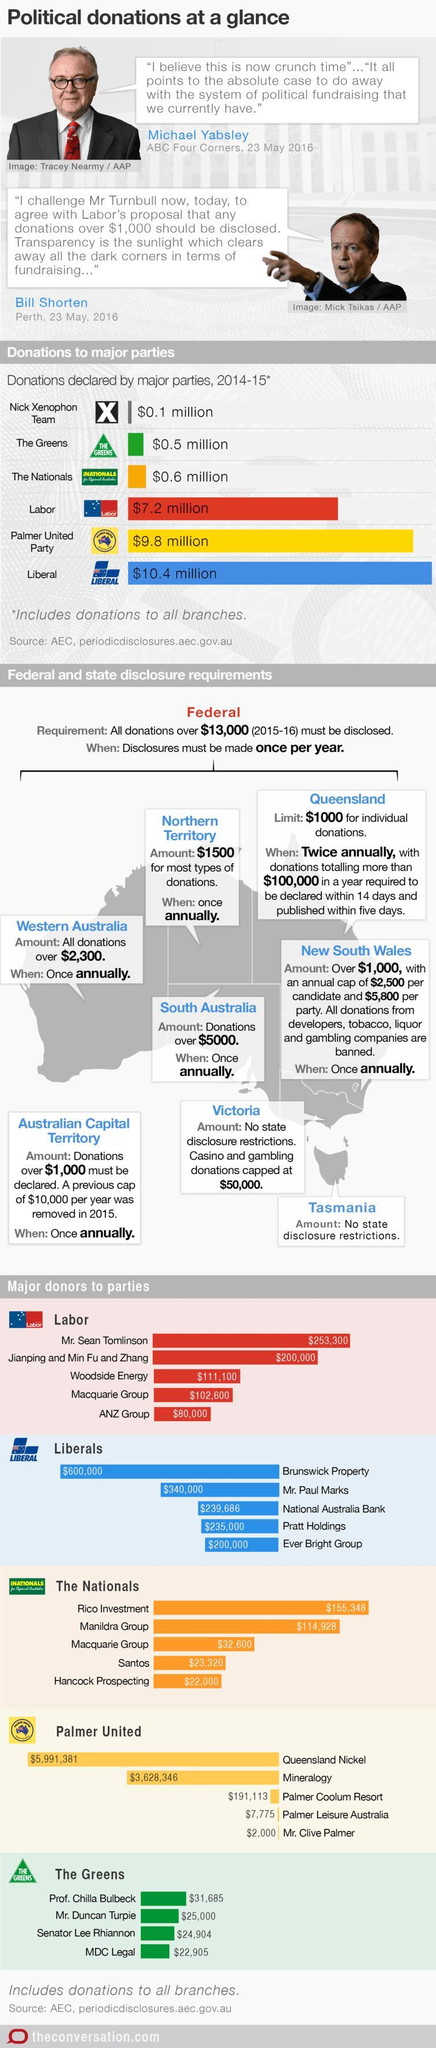What alphabet is written inside the logo of Nick Xenophon Team
Answer the question with a short phrase. X Who was the second highest donor to Labor party Jianping and Min Fu and Zhang What is the total donation in million dollars by Nick Xenophon Team and The Greens 0.6 How much in dollars did MDC Legal and Mr. Duncan Turpie donate to the Greens 47,905 How much in million dollars was donated by Palmer United Party and Liberal 11.2 What has been the donation in dollars by Mr. Clive Palmer and Palmer Leisure Australia to Palmer United 9775 